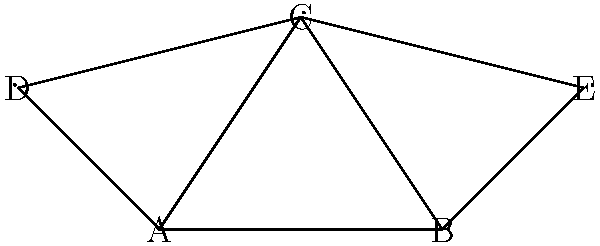In the given social network graph representing influencers spreading new catchphrases, which node has the highest degree centrality? How does this impact the spread of new catchphrases across different social media platforms? To determine the node with the highest degree centrality and its impact on spreading catchphrases, we'll follow these steps:

1. Calculate the degree centrality for each node:
   - Node A: Connected to B, C, D (degree = 3)
   - Node B: Connected to A, C, E (degree = 3)
   - Node C: Connected to A, B, D, E (degree = 4)
   - Node D: Connected to A, C (degree = 2)
   - Node E: Connected to B, C (degree = 2)

2. Identify the node with the highest degree centrality:
   Node C has the highest degree centrality with 4 connections.

3. Analyze the impact on spreading catchphrases:
   - Higher degree centrality means more direct connections to other influencers.
   - Node C can directly share new catchphrases with 4 other influencers, potentially reaching a larger audience faster.
   - This central position allows for quicker dissemination of new catchphrases across different social media platforms.
   - The influencer represented by Node C acts as a hub, facilitating the spread of catchphrases to various parts of the network.
   - Other influencers (A, B, D, E) are more likely to encounter new catchphrases through Node C, increasing the phrases' visibility and adoption rate.

4. Cross-platform impact:
   - If each node represents an influencer on a different social media platform, Node C's high centrality suggests it has connections across multiple platforms.
   - This cross-platform reach enhances the potential for catchphrases to spread beyond a single social media ecosystem, increasing their overall impact and adoption.

In conclusion, Node C's high degree centrality positions it as a key player in the rapid and widespread dissemination of new catchphrases across various social media platforms.
Answer: Node C; facilitates rapid, widespread catchphrase dissemination across platforms. 